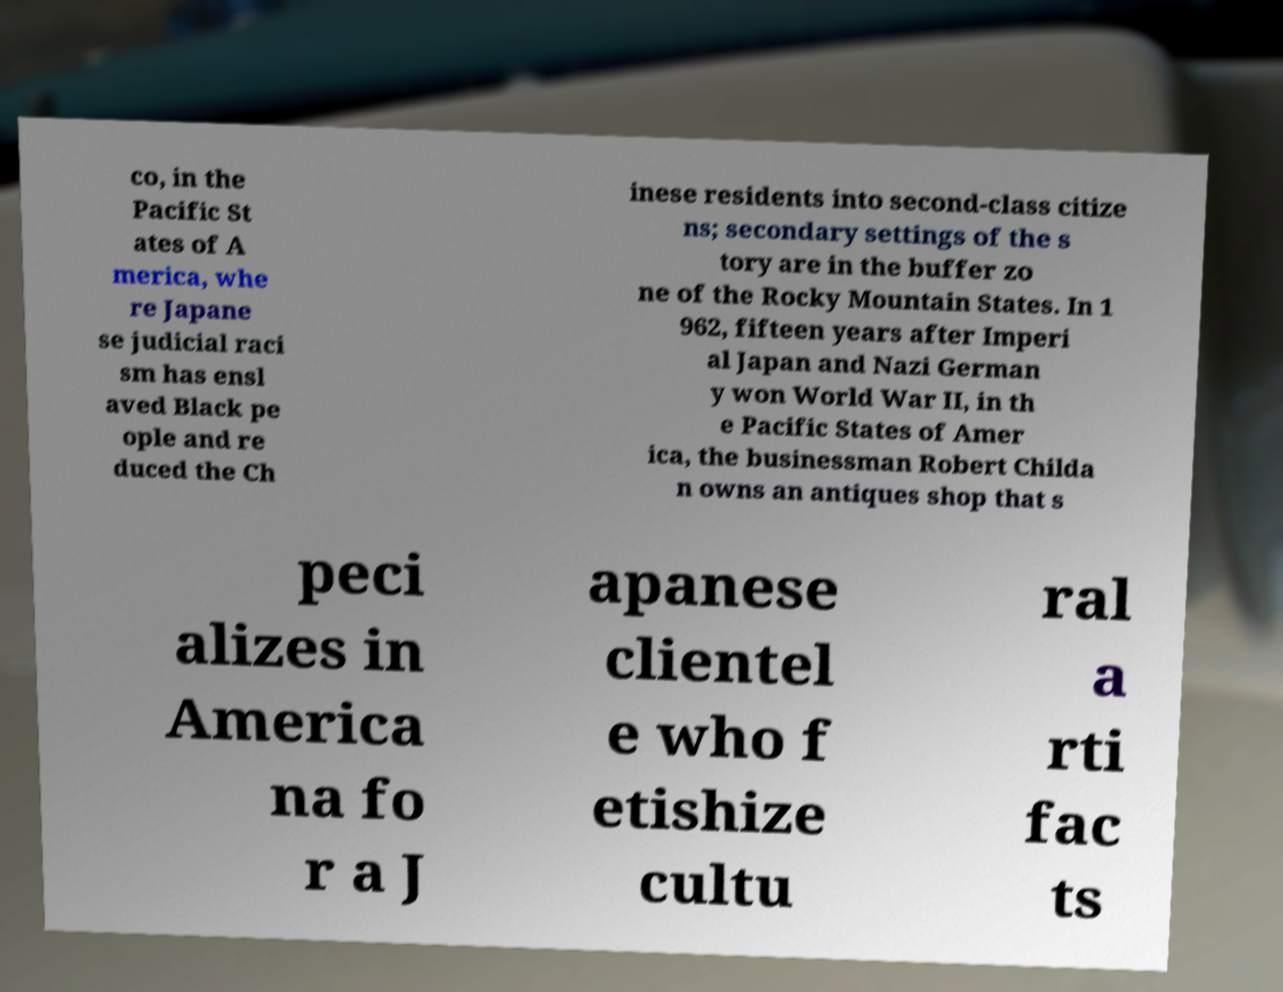I need the written content from this picture converted into text. Can you do that? co, in the Pacific St ates of A merica, whe re Japane se judicial raci sm has ensl aved Black pe ople and re duced the Ch inese residents into second-class citize ns; secondary settings of the s tory are in the buffer zo ne of the Rocky Mountain States. In 1 962, fifteen years after Imperi al Japan and Nazi German y won World War II, in th e Pacific States of Amer ica, the businessman Robert Childa n owns an antiques shop that s peci alizes in America na fo r a J apanese clientel e who f etishize cultu ral a rti fac ts 